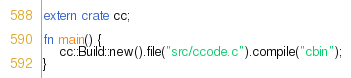<code> <loc_0><loc_0><loc_500><loc_500><_Rust_>extern crate cc;

fn main() {
    cc::Build::new().file("src/ccode.c").compile("cbin");
}
</code> 